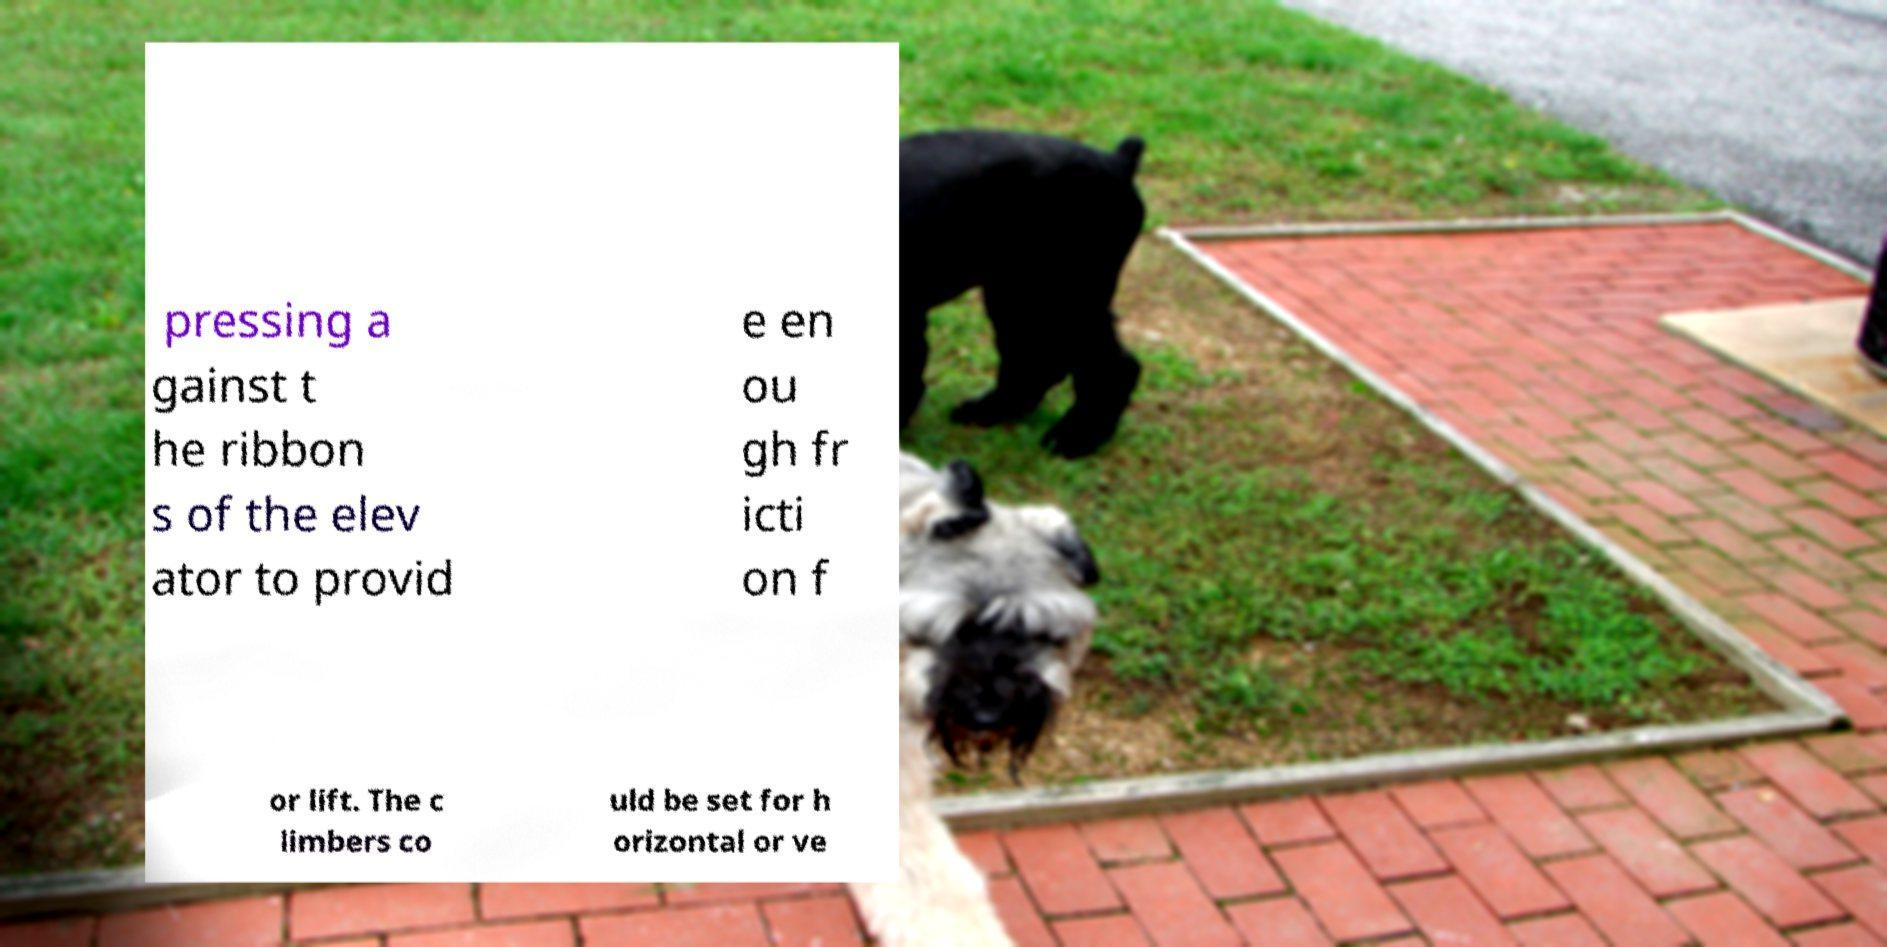Can you accurately transcribe the text from the provided image for me? pressing a gainst t he ribbon s of the elev ator to provid e en ou gh fr icti on f or lift. The c limbers co uld be set for h orizontal or ve 